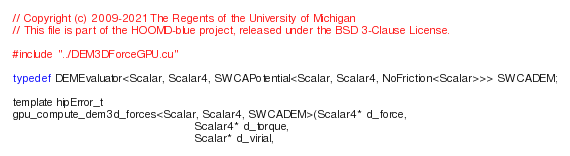<code> <loc_0><loc_0><loc_500><loc_500><_Cuda_>// Copyright (c) 2009-2021 The Regents of the University of Michigan
// This file is part of the HOOMD-blue project, released under the BSD 3-Clause License.

#include "../DEM3DForceGPU.cu"

typedef DEMEvaluator<Scalar, Scalar4, SWCAPotential<Scalar, Scalar4, NoFriction<Scalar>>> SWCADEM;

template hipError_t
gpu_compute_dem3d_forces<Scalar, Scalar4, SWCADEM>(Scalar4* d_force,
                                                   Scalar4* d_torque,
                                                   Scalar* d_virial,</code> 